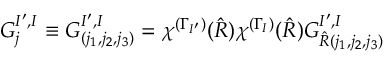<formula> <loc_0><loc_0><loc_500><loc_500>G _ { j } ^ { I ^ { \prime } , I } \equiv G _ { ( j _ { 1 } , j _ { 2 } , j _ { 3 } ) } ^ { I ^ { \prime } , I } = \chi ^ { ( \Gamma _ { I ^ { \prime } } ) } ( \hat { R } ) \chi ^ { ( \Gamma _ { I } ) } ( \hat { R } ) G _ { \hat { R } ( j _ { 1 } , j _ { 2 } , j _ { 3 } ) } ^ { I ^ { \prime } , I }</formula> 